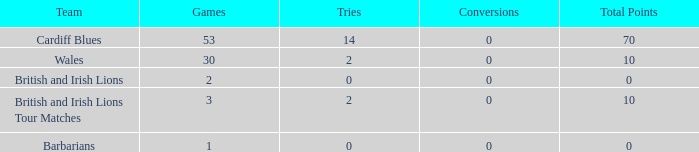What is the average number of conversions for the Cardiff Blues with less than 14 tries? None. 